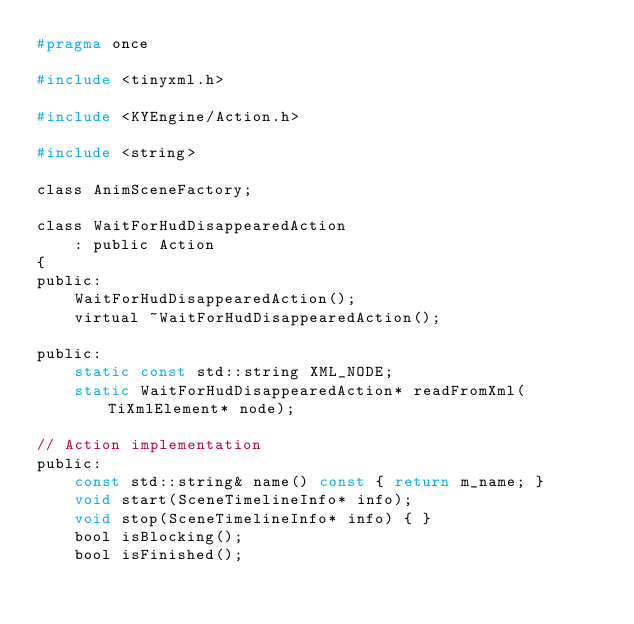<code> <loc_0><loc_0><loc_500><loc_500><_C_>#pragma once

#include <tinyxml.h>

#include <KYEngine/Action.h>

#include <string>

class AnimSceneFactory;

class WaitForHudDisappearedAction
	: public Action
{
public:
	WaitForHudDisappearedAction();
	virtual ~WaitForHudDisappearedAction();
	
public:
	static const std::string XML_NODE;
	static WaitForHudDisappearedAction* readFromXml(TiXmlElement* node);
	
// Action implementation
public:
	const std::string& name() const { return m_name; }
	void start(SceneTimelineInfo* info);
    void stop(SceneTimelineInfo* info) { }
	bool isBlocking();
	bool isFinished();</code> 